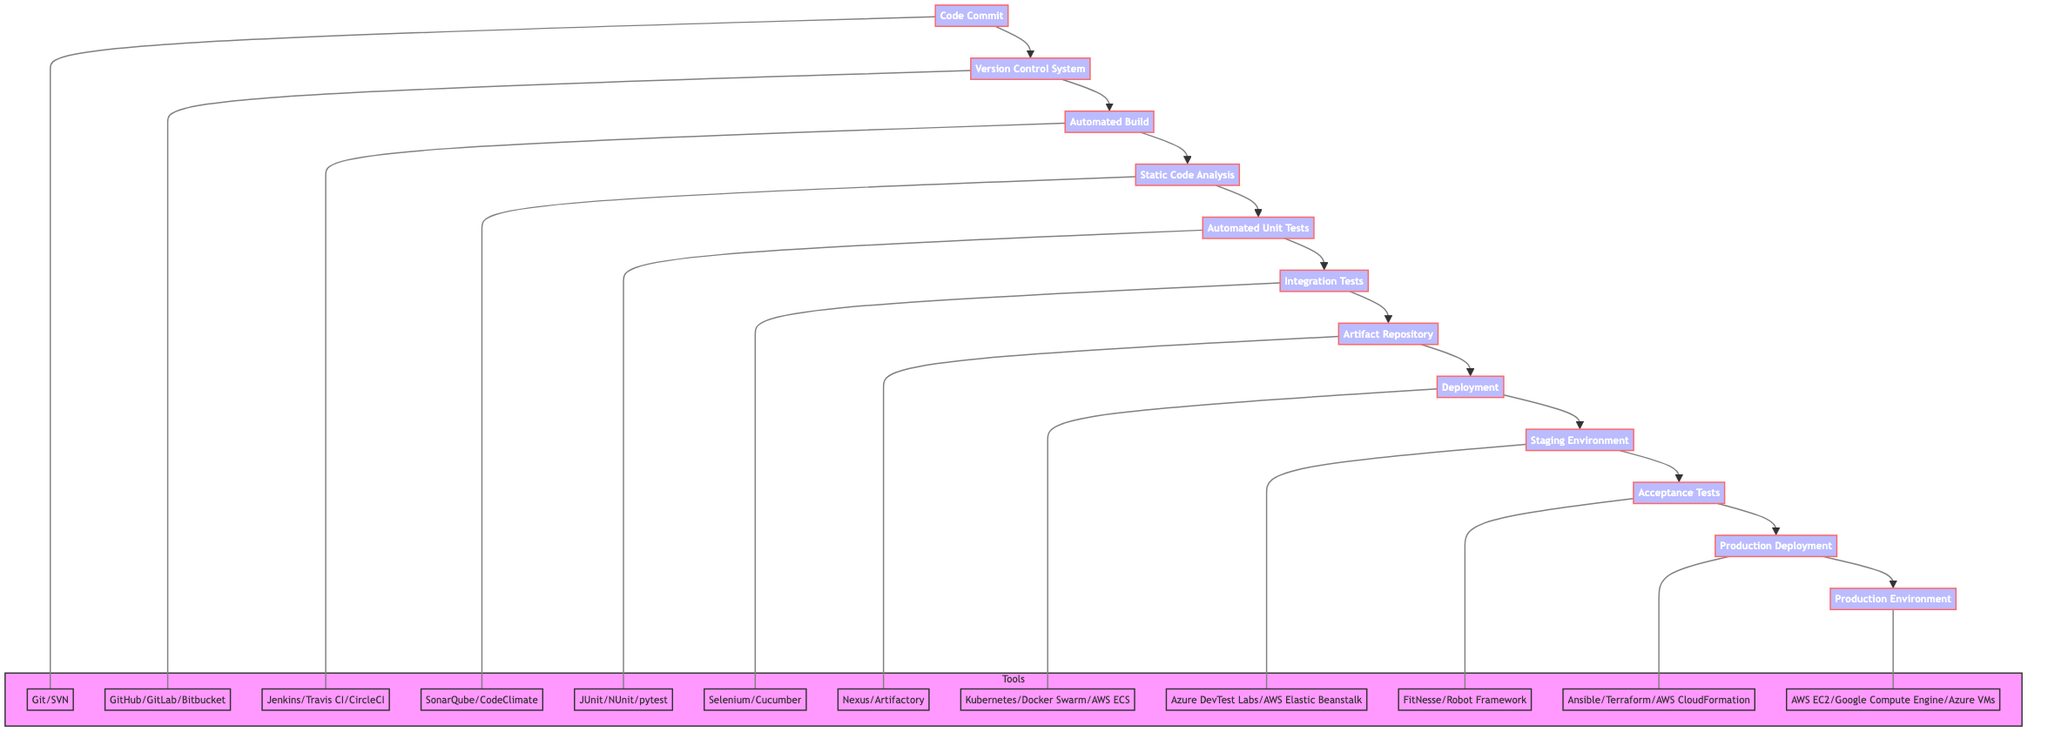What is the first step in the Continuous Integration Pipeline? The first step is "Code Commit," which represents the action where developers commit code changes to the version control system.
Answer: Code Commit How many steps are there in the Continuous Integration Pipeline? By counting from "Code Commit" to "Production Environment," there are a total of 12 steps in the pipeline.
Answer: 12 What tools are associated with the "Automated Build" step? The tools related to the "Automated Build" step are Jenkins, Travis CI, and CircleCI.
Answer: Jenkins, Travis CI, CircleCI What is the last step before production deployment? The last step before production deployment is "Acceptance Tests," which verifies that the application meets business requirements.
Answer: Acceptance Tests Which step comes after "Integration Tests"? The step that follows "Integration Tests" is "Artifact Repository," where built artifacts are stored.
Answer: Artifact Repository What is the purpose of the "Staging Environment"? The purpose of the "Staging Environment" is to test the application in an environment that closely mirrors production before it goes live.
Answer: Test the application Which tools are used for Deployment? The tools used for Deployment are Kubernetes, Docker Swarm, and AWS ECS.
Answer: Kubernetes, Docker Swarm, AWS ECS How are "Automated Unit Tests" and "Static Code Analysis" linked? "Automated Unit Tests" follows "Static Code Analysis," meaning unit tests are run after the code has been analyzed for potential errors and best practices.
Answer: Automated Unit Tests What is the role of the "Version Control System"? The "Version Control System" stores and manages code changes made by developers, providing a history of modifications.
Answer: Store and manage code changes Which step directly precedes "Production Environment"? The step that comes right before "Production Environment" is "Production Deployment," where the tested build is deployed live for end users.
Answer: Production Deployment 